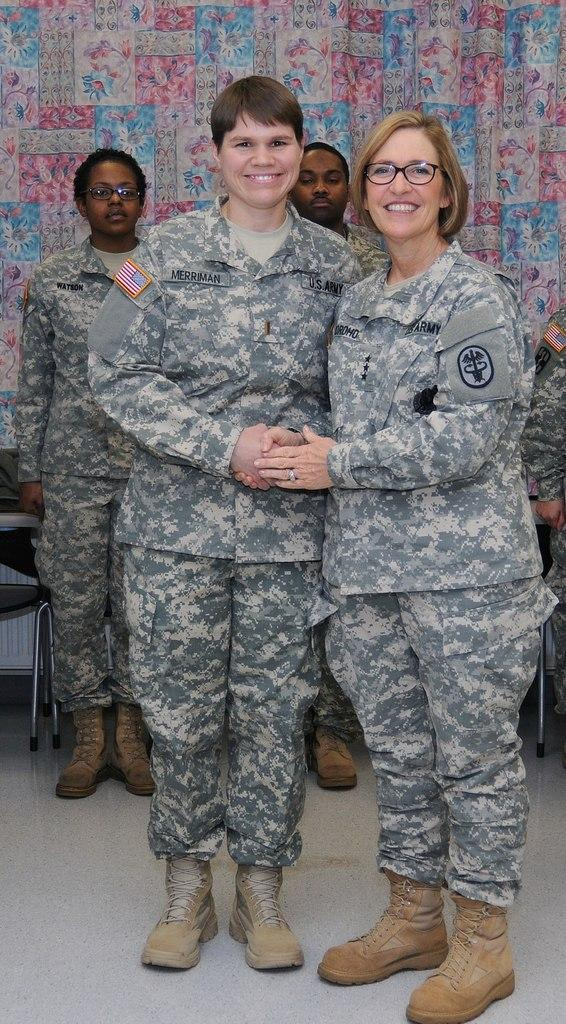What are the two people in the image doing? The two people in the image are standing and smiling. What can be seen hanging in the image? There is a curtain hanging in the image. What type of furniture is present in the image? There is a chair in the image. What can be seen in the background of the image? In the background, there are few people standing. What type of badge is the person wearing in the image? There is no person wearing a badge in the image. What is the limit of the chair in the image? The chair in the image does not have a limit; it is a stationary piece of furniture. 